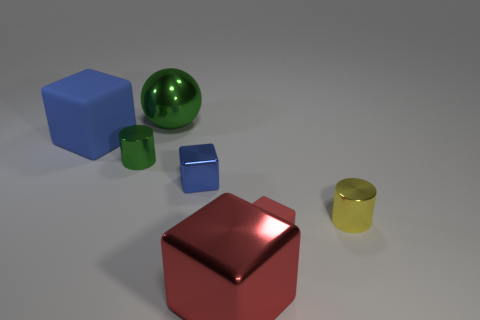Can you describe the light source in the image? The light source isn't visible in the image directly, but based on the shadows and highlights, it seems to be situated above the objects, slightly to the left side, casting a soft, diffused light. 